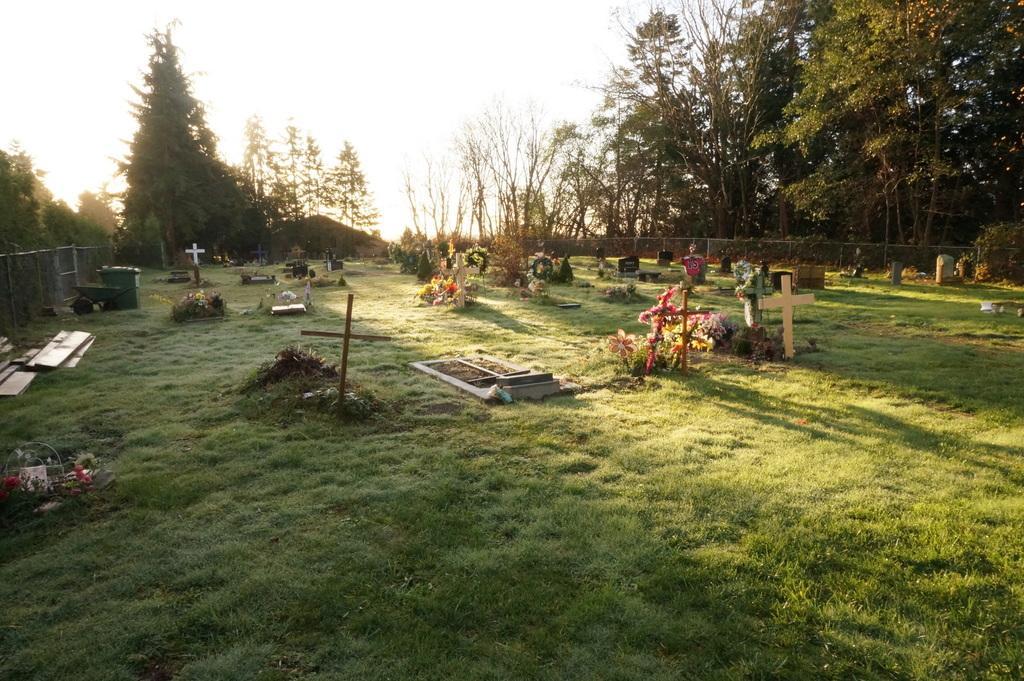Describe this image in one or two sentences. In this image I can see an open grass ground and on it I can see shadows, flowers, tombstones and few wooden crosses. In the background I can see number of trees, the sky and fencing on the both sides of the image. On the left side of the image I can see a container and a trolley. 